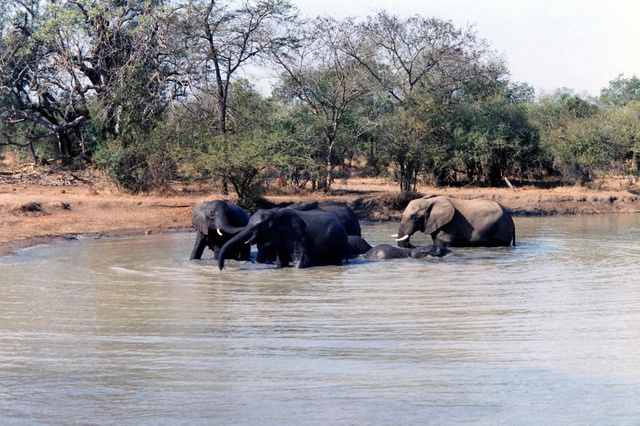Describe the objects in this image and their specific colors. I can see elephant in gray, black, navy, and darkblue tones, elephant in gray, black, tan, and darkgray tones, elephant in gray, black, and navy tones, elephant in gray, black, and darkgray tones, and elephant in gray, black, and navy tones in this image. 